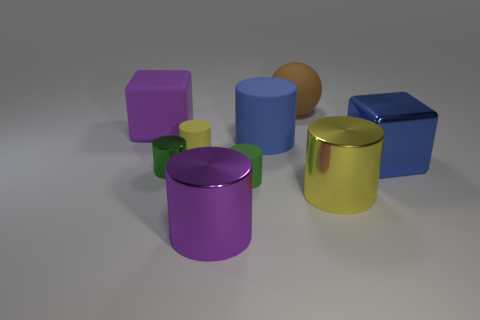The cylinder that is the same color as the small metal object is what size?
Ensure brevity in your answer.  Small. Is there a green metallic thing that is on the left side of the block that is left of the big object that is behind the purple cube?
Keep it short and to the point. No. There is a big shiny thing that is the same color as the matte block; what shape is it?
Your answer should be very brief. Cylinder. How many tiny objects are either green objects or yellow metal cylinders?
Offer a very short reply. 2. Does the tiny matte thing that is left of the small green rubber cylinder have the same shape as the green rubber thing?
Keep it short and to the point. Yes. Is the number of purple cylinders less than the number of metallic balls?
Ensure brevity in your answer.  No. Is there any other thing that is the same color as the big rubber sphere?
Offer a terse response. No. What is the shape of the yellow thing that is in front of the big metallic cube?
Provide a short and direct response. Cylinder. Is the color of the big rubber cube the same as the big metal cylinder left of the blue cylinder?
Give a very brief answer. Yes. Is the number of brown rubber objects that are in front of the purple metal object the same as the number of brown rubber balls that are on the left side of the small green metallic thing?
Your response must be concise. Yes. 